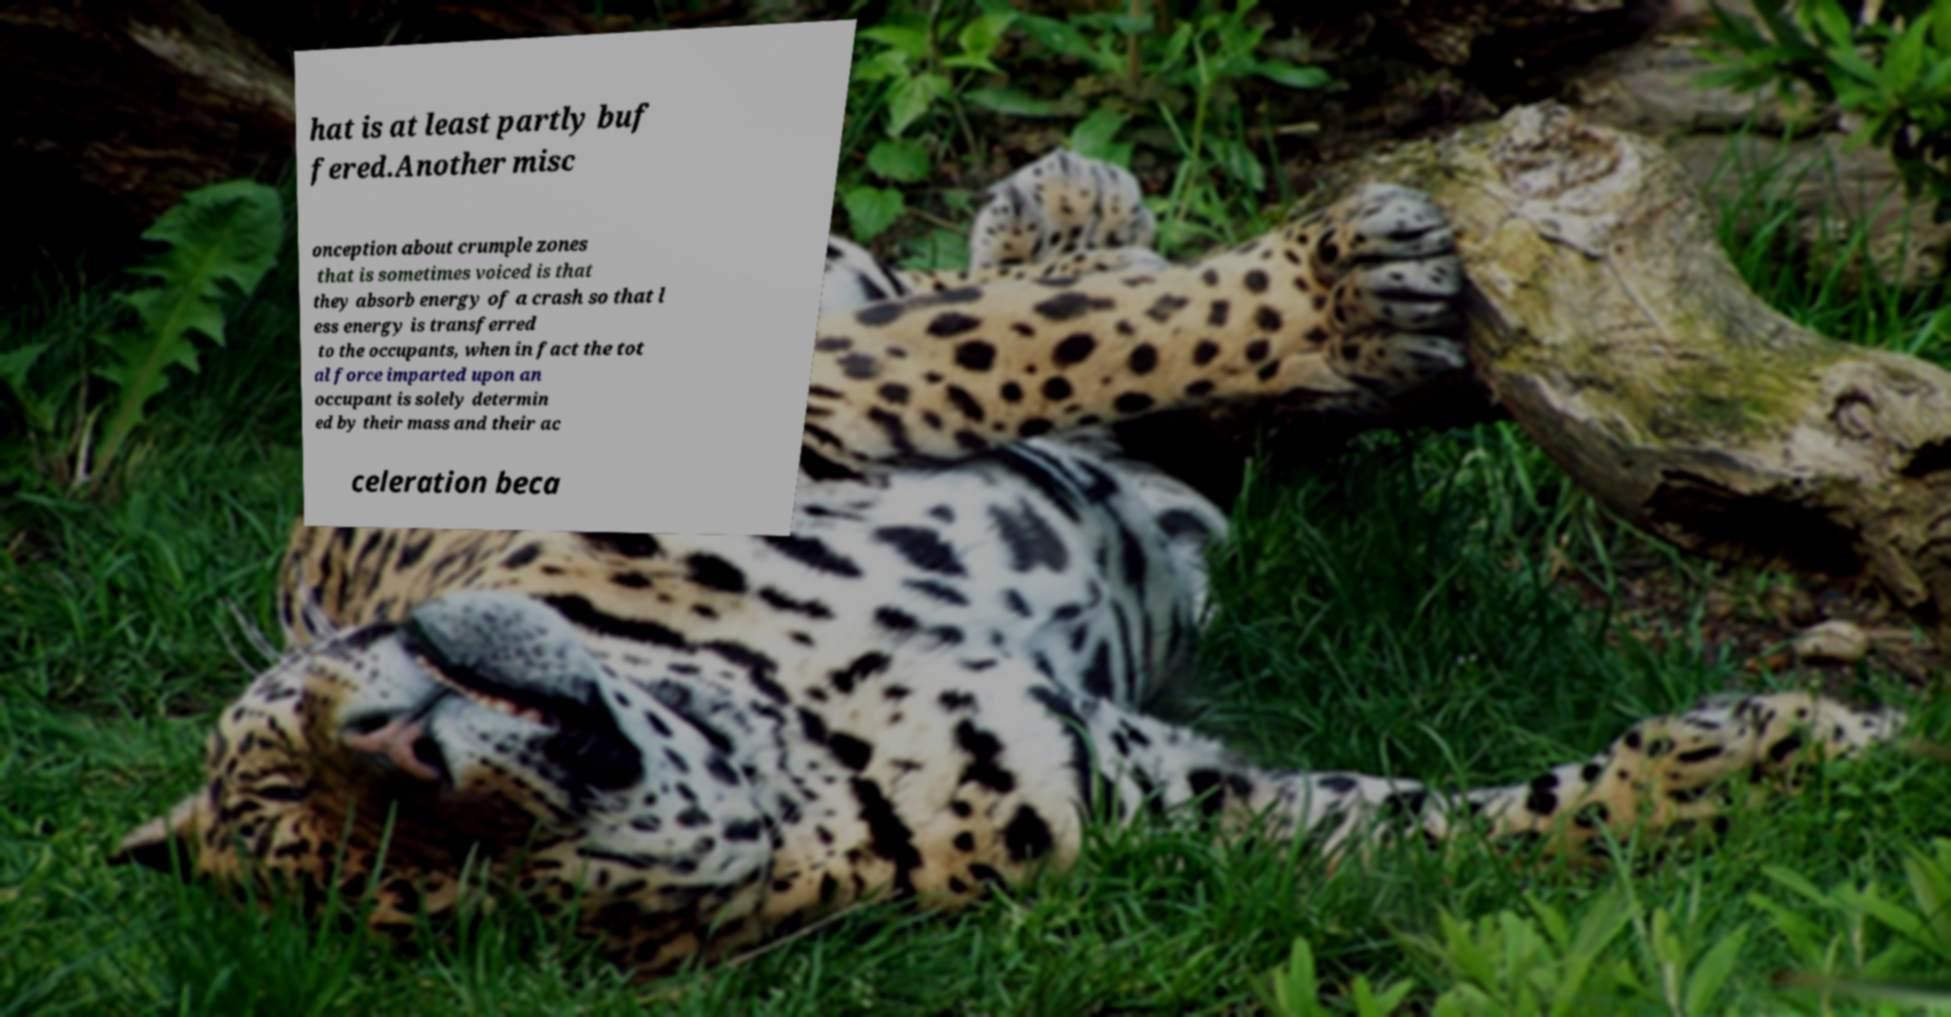I need the written content from this picture converted into text. Can you do that? hat is at least partly buf fered.Another misc onception about crumple zones that is sometimes voiced is that they absorb energy of a crash so that l ess energy is transferred to the occupants, when in fact the tot al force imparted upon an occupant is solely determin ed by their mass and their ac celeration beca 